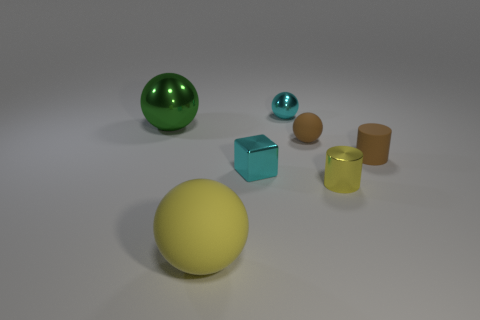What is the approximate arrangement of the objects in the image? The objects are dispersed with no specific pattern on a flat surface. A large yellow ball is placed prominently in the foreground while a large green ball, a small blue ball, two cylinders, and a cube rest in the mid to background, casually arranged. 